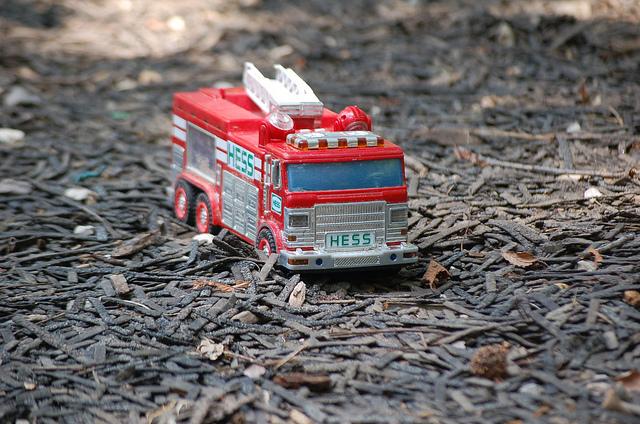What kind of truck is this?
Write a very short answer. Fire truck. Is this a toy?
Quick response, please. Yes. What color is the toy?
Write a very short answer. Red. 